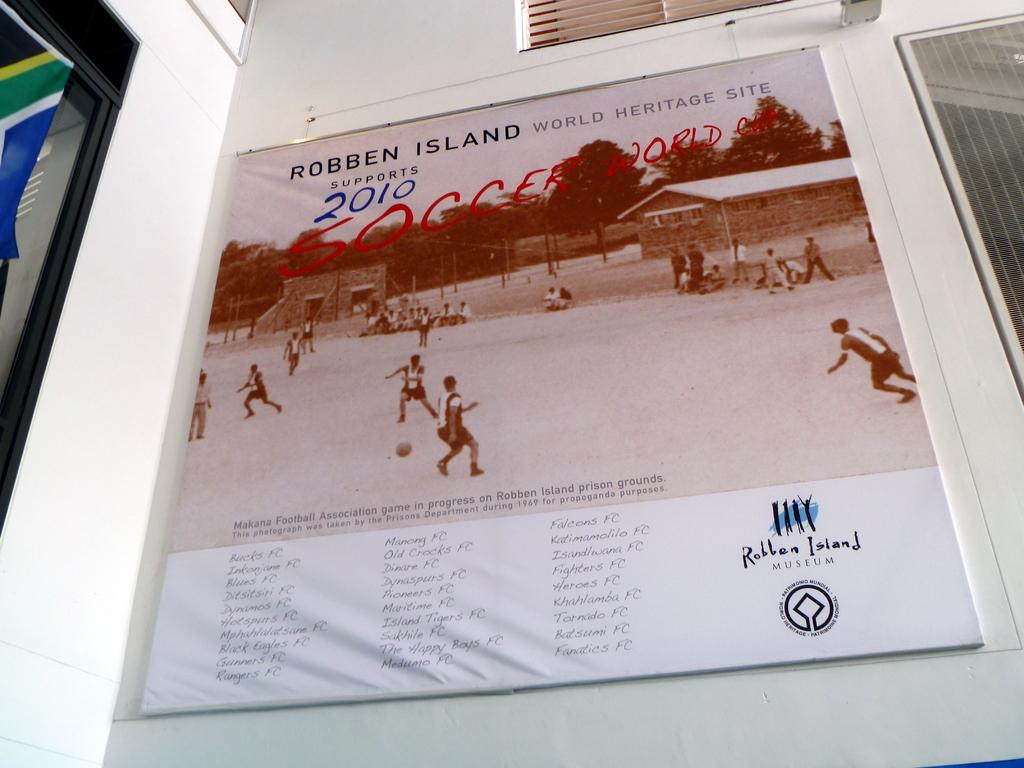Provide a one-sentence caption for the provided image. Robben Island world heritage site billboard sign in white. 